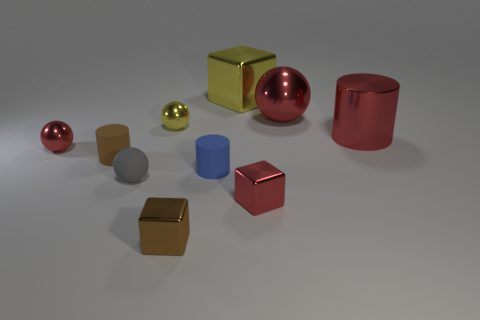What is the color of the metallic object that is in front of the big metallic ball and to the right of the red metallic cube?
Your answer should be very brief. Red. Are there the same number of blue rubber things that are left of the red metallic cylinder and yellow metal blocks that are to the left of the small blue object?
Your answer should be very brief. No. There is a sphere that is made of the same material as the tiny brown cylinder; what color is it?
Your answer should be compact. Gray. There is a big metallic block; is it the same color as the tiny ball that is right of the tiny rubber ball?
Offer a very short reply. Yes. There is a metallic block right of the thing behind the large red shiny sphere; are there any brown things that are on the left side of it?
Provide a short and direct response. Yes. There is a brown object that is made of the same material as the gray thing; what shape is it?
Provide a short and direct response. Cylinder. There is a tiny brown shiny object; what shape is it?
Ensure brevity in your answer.  Cube. There is a large red metallic object behind the large red metallic cylinder; is its shape the same as the small gray object?
Keep it short and to the point. Yes. Is the number of large red cylinders to the left of the small blue matte thing greater than the number of shiny cubes left of the tiny gray ball?
Keep it short and to the point. No. What number of other things are there of the same size as the gray sphere?
Keep it short and to the point. 6. 